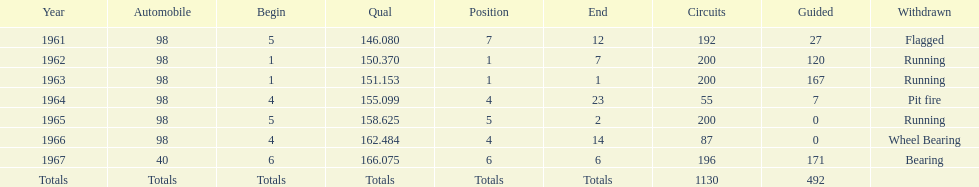What car ranked #1 from 1962-1963? 98. 